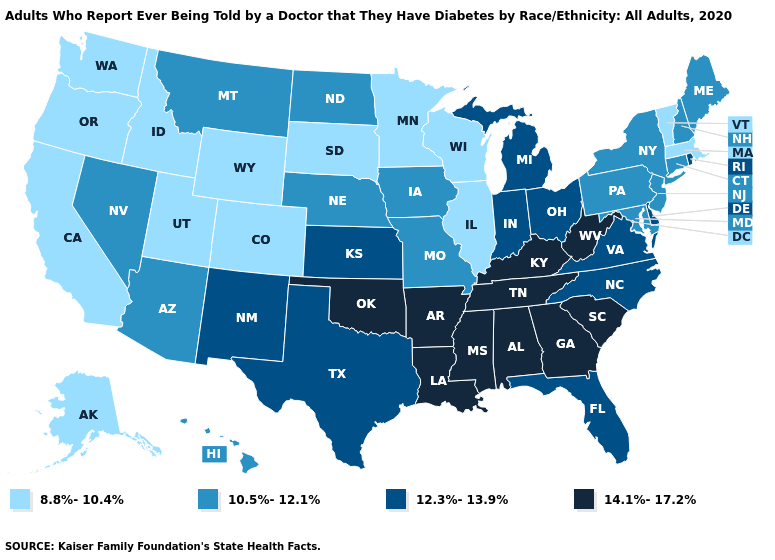Among the states that border Alabama , which have the highest value?
Write a very short answer. Georgia, Mississippi, Tennessee. Which states have the highest value in the USA?
Keep it brief. Alabama, Arkansas, Georgia, Kentucky, Louisiana, Mississippi, Oklahoma, South Carolina, Tennessee, West Virginia. What is the value of New Jersey?
Quick response, please. 10.5%-12.1%. Does Rhode Island have the same value as Florida?
Short answer required. Yes. Among the states that border Massachusetts , does Vermont have the lowest value?
Keep it brief. Yes. What is the value of Virginia?
Short answer required. 12.3%-13.9%. Name the states that have a value in the range 8.8%-10.4%?
Write a very short answer. Alaska, California, Colorado, Idaho, Illinois, Massachusetts, Minnesota, Oregon, South Dakota, Utah, Vermont, Washington, Wisconsin, Wyoming. Among the states that border Iowa , does South Dakota have the highest value?
Be succinct. No. Name the states that have a value in the range 8.8%-10.4%?
Be succinct. Alaska, California, Colorado, Idaho, Illinois, Massachusetts, Minnesota, Oregon, South Dakota, Utah, Vermont, Washington, Wisconsin, Wyoming. Does the first symbol in the legend represent the smallest category?
Answer briefly. Yes. Which states have the lowest value in the Northeast?
Concise answer only. Massachusetts, Vermont. Name the states that have a value in the range 14.1%-17.2%?
Concise answer only. Alabama, Arkansas, Georgia, Kentucky, Louisiana, Mississippi, Oklahoma, South Carolina, Tennessee, West Virginia. Does the first symbol in the legend represent the smallest category?
Concise answer only. Yes. Name the states that have a value in the range 12.3%-13.9%?
Concise answer only. Delaware, Florida, Indiana, Kansas, Michigan, New Mexico, North Carolina, Ohio, Rhode Island, Texas, Virginia. What is the highest value in the West ?
Answer briefly. 12.3%-13.9%. 